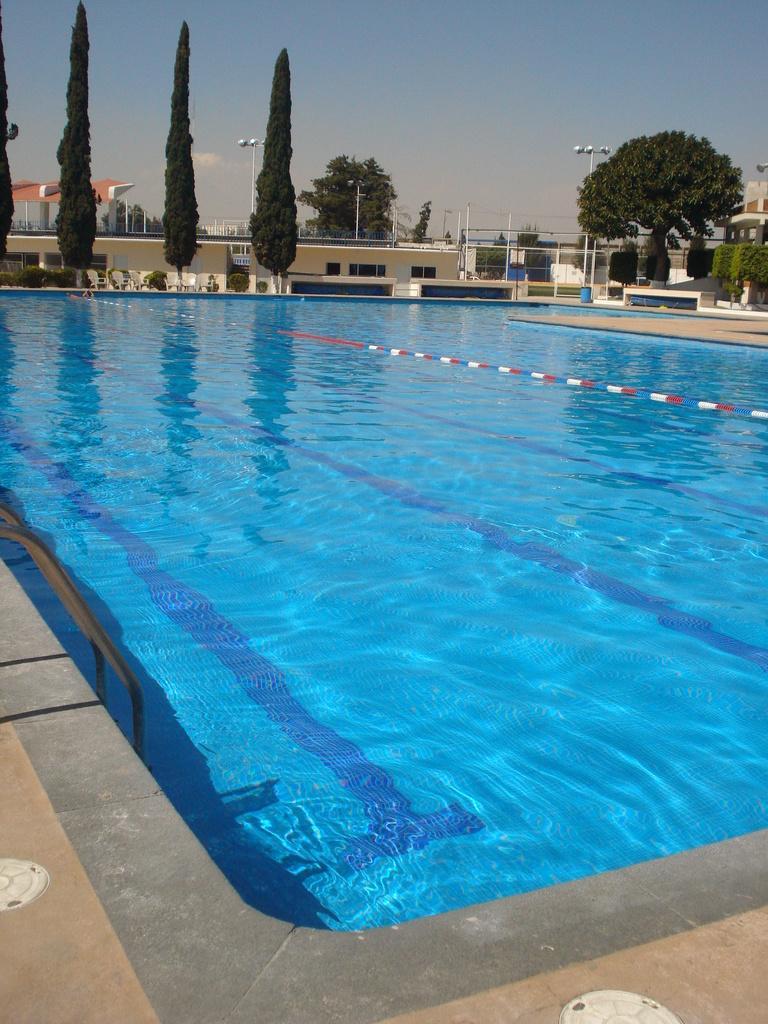Please provide a concise description of this image. On the right side, there is a swimming pool having water in it. In the background, there are trees, poles, buildings and there are clouds in the blue sky. 